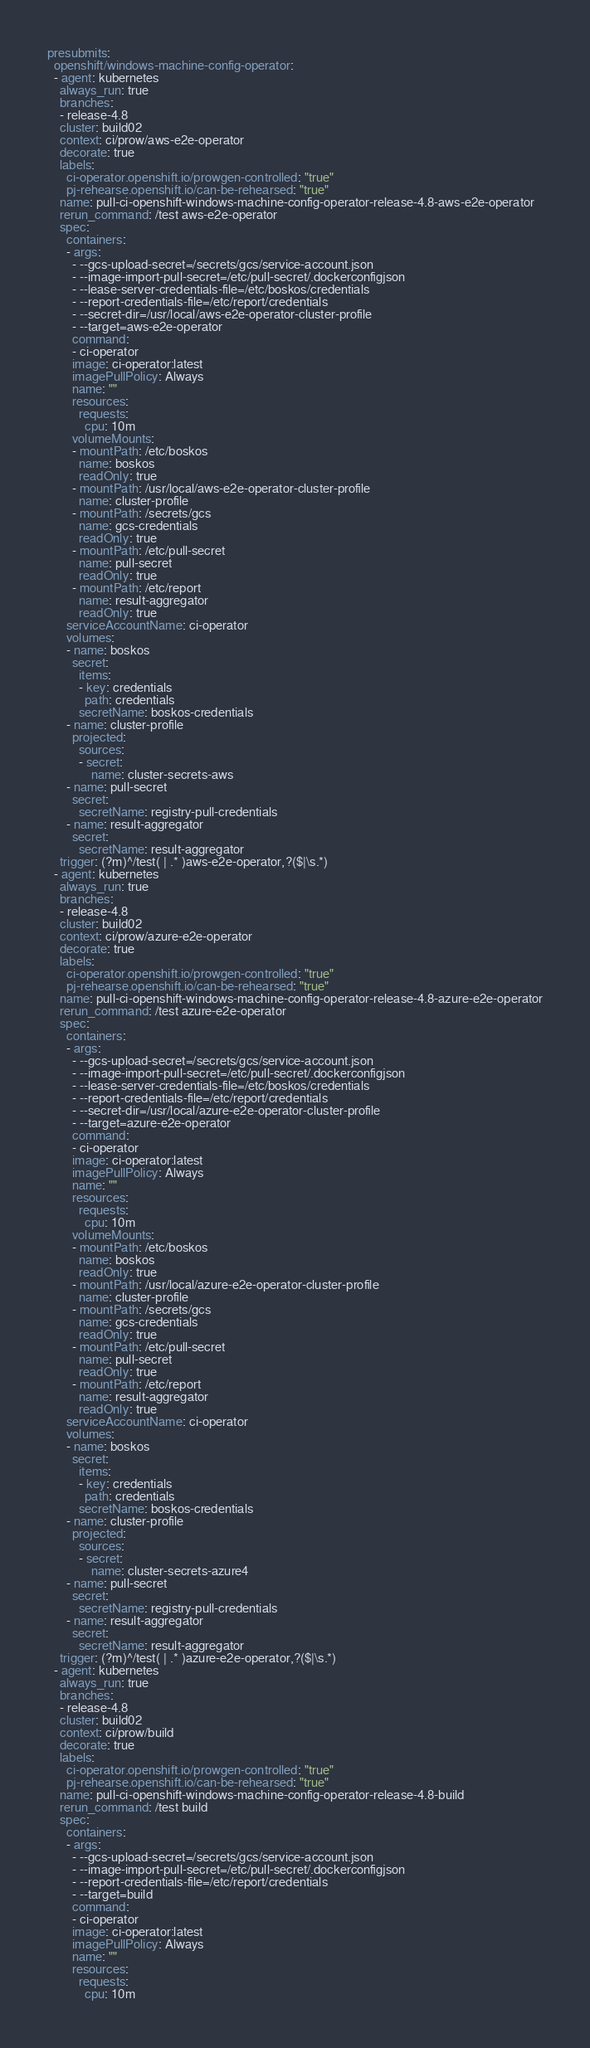<code> <loc_0><loc_0><loc_500><loc_500><_YAML_>presubmits:
  openshift/windows-machine-config-operator:
  - agent: kubernetes
    always_run: true
    branches:
    - release-4.8
    cluster: build02
    context: ci/prow/aws-e2e-operator
    decorate: true
    labels:
      ci-operator.openshift.io/prowgen-controlled: "true"
      pj-rehearse.openshift.io/can-be-rehearsed: "true"
    name: pull-ci-openshift-windows-machine-config-operator-release-4.8-aws-e2e-operator
    rerun_command: /test aws-e2e-operator
    spec:
      containers:
      - args:
        - --gcs-upload-secret=/secrets/gcs/service-account.json
        - --image-import-pull-secret=/etc/pull-secret/.dockerconfigjson
        - --lease-server-credentials-file=/etc/boskos/credentials
        - --report-credentials-file=/etc/report/credentials
        - --secret-dir=/usr/local/aws-e2e-operator-cluster-profile
        - --target=aws-e2e-operator
        command:
        - ci-operator
        image: ci-operator:latest
        imagePullPolicy: Always
        name: ""
        resources:
          requests:
            cpu: 10m
        volumeMounts:
        - mountPath: /etc/boskos
          name: boskos
          readOnly: true
        - mountPath: /usr/local/aws-e2e-operator-cluster-profile
          name: cluster-profile
        - mountPath: /secrets/gcs
          name: gcs-credentials
          readOnly: true
        - mountPath: /etc/pull-secret
          name: pull-secret
          readOnly: true
        - mountPath: /etc/report
          name: result-aggregator
          readOnly: true
      serviceAccountName: ci-operator
      volumes:
      - name: boskos
        secret:
          items:
          - key: credentials
            path: credentials
          secretName: boskos-credentials
      - name: cluster-profile
        projected:
          sources:
          - secret:
              name: cluster-secrets-aws
      - name: pull-secret
        secret:
          secretName: registry-pull-credentials
      - name: result-aggregator
        secret:
          secretName: result-aggregator
    trigger: (?m)^/test( | .* )aws-e2e-operator,?($|\s.*)
  - agent: kubernetes
    always_run: true
    branches:
    - release-4.8
    cluster: build02
    context: ci/prow/azure-e2e-operator
    decorate: true
    labels:
      ci-operator.openshift.io/prowgen-controlled: "true"
      pj-rehearse.openshift.io/can-be-rehearsed: "true"
    name: pull-ci-openshift-windows-machine-config-operator-release-4.8-azure-e2e-operator
    rerun_command: /test azure-e2e-operator
    spec:
      containers:
      - args:
        - --gcs-upload-secret=/secrets/gcs/service-account.json
        - --image-import-pull-secret=/etc/pull-secret/.dockerconfigjson
        - --lease-server-credentials-file=/etc/boskos/credentials
        - --report-credentials-file=/etc/report/credentials
        - --secret-dir=/usr/local/azure-e2e-operator-cluster-profile
        - --target=azure-e2e-operator
        command:
        - ci-operator
        image: ci-operator:latest
        imagePullPolicy: Always
        name: ""
        resources:
          requests:
            cpu: 10m
        volumeMounts:
        - mountPath: /etc/boskos
          name: boskos
          readOnly: true
        - mountPath: /usr/local/azure-e2e-operator-cluster-profile
          name: cluster-profile
        - mountPath: /secrets/gcs
          name: gcs-credentials
          readOnly: true
        - mountPath: /etc/pull-secret
          name: pull-secret
          readOnly: true
        - mountPath: /etc/report
          name: result-aggregator
          readOnly: true
      serviceAccountName: ci-operator
      volumes:
      - name: boskos
        secret:
          items:
          - key: credentials
            path: credentials
          secretName: boskos-credentials
      - name: cluster-profile
        projected:
          sources:
          - secret:
              name: cluster-secrets-azure4
      - name: pull-secret
        secret:
          secretName: registry-pull-credentials
      - name: result-aggregator
        secret:
          secretName: result-aggregator
    trigger: (?m)^/test( | .* )azure-e2e-operator,?($|\s.*)
  - agent: kubernetes
    always_run: true
    branches:
    - release-4.8
    cluster: build02
    context: ci/prow/build
    decorate: true
    labels:
      ci-operator.openshift.io/prowgen-controlled: "true"
      pj-rehearse.openshift.io/can-be-rehearsed: "true"
    name: pull-ci-openshift-windows-machine-config-operator-release-4.8-build
    rerun_command: /test build
    spec:
      containers:
      - args:
        - --gcs-upload-secret=/secrets/gcs/service-account.json
        - --image-import-pull-secret=/etc/pull-secret/.dockerconfigjson
        - --report-credentials-file=/etc/report/credentials
        - --target=build
        command:
        - ci-operator
        image: ci-operator:latest
        imagePullPolicy: Always
        name: ""
        resources:
          requests:
            cpu: 10m</code> 